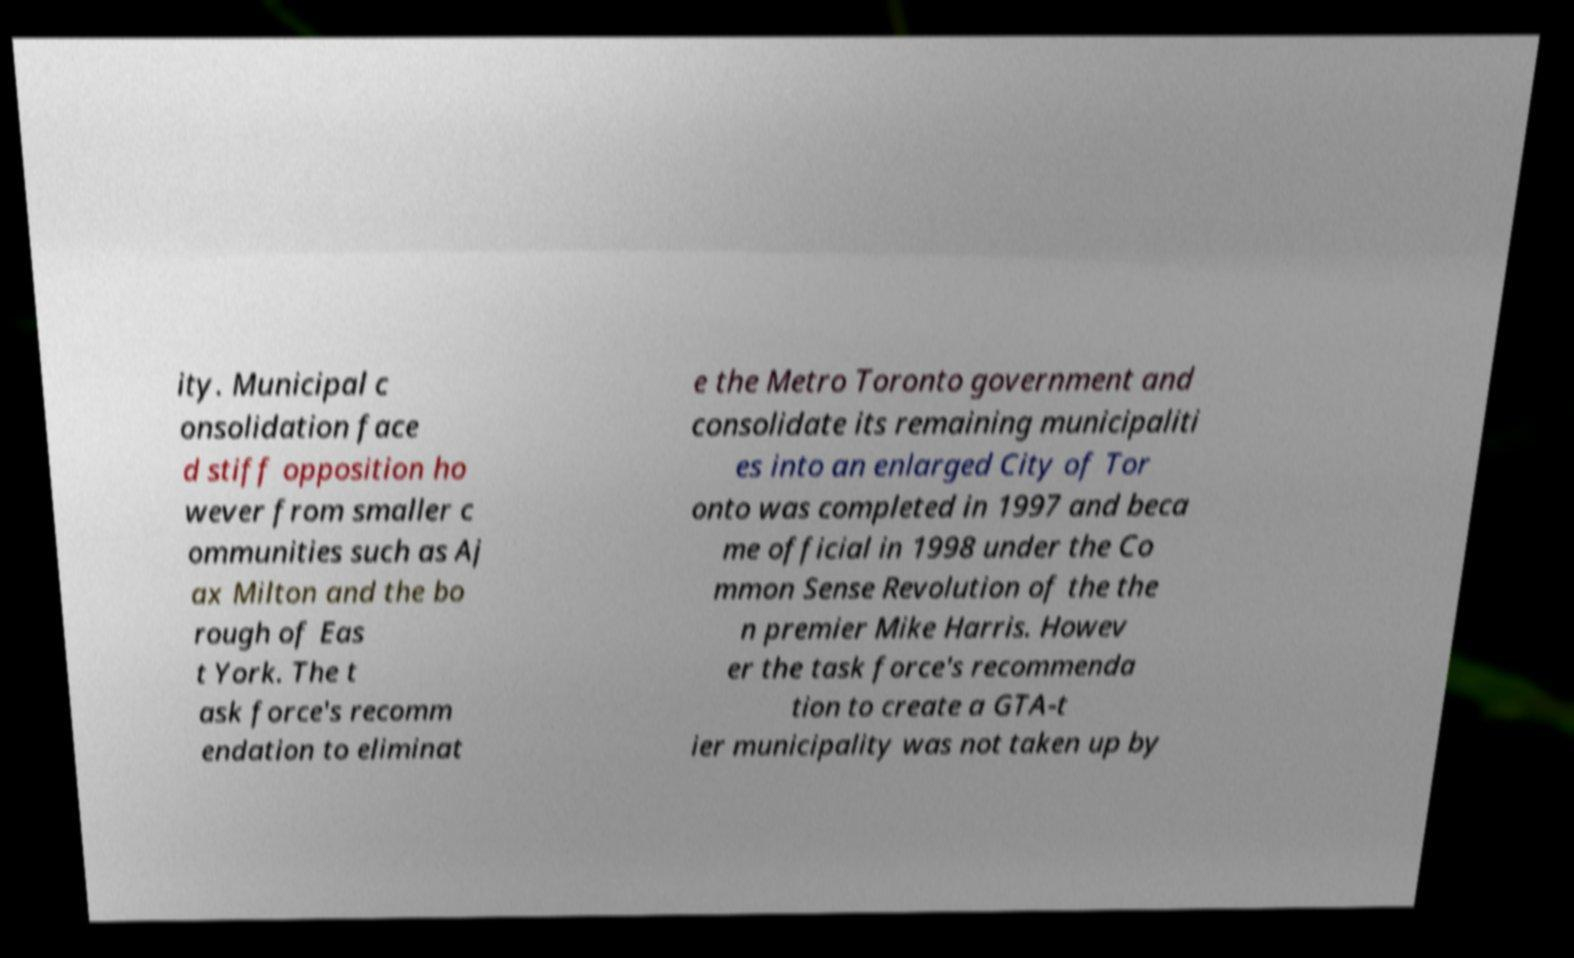What messages or text are displayed in this image? I need them in a readable, typed format. ity. Municipal c onsolidation face d stiff opposition ho wever from smaller c ommunities such as Aj ax Milton and the bo rough of Eas t York. The t ask force's recomm endation to eliminat e the Metro Toronto government and consolidate its remaining municipaliti es into an enlarged City of Tor onto was completed in 1997 and beca me official in 1998 under the Co mmon Sense Revolution of the the n premier Mike Harris. Howev er the task force's recommenda tion to create a GTA-t ier municipality was not taken up by 